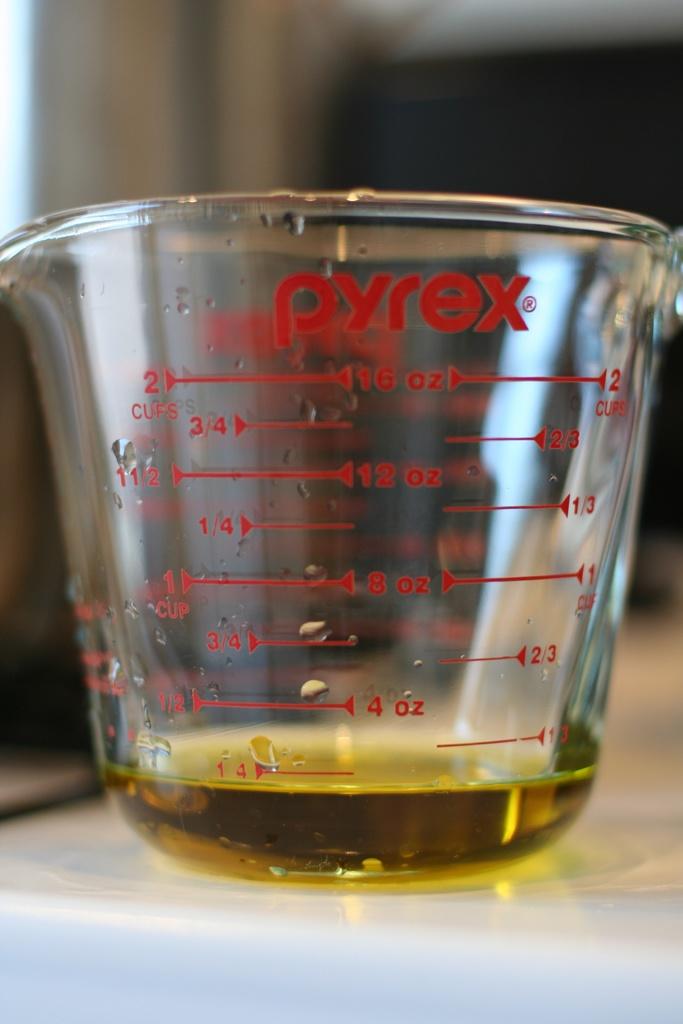What is the oil measurement?
Keep it short and to the point. 1/4 cup. What brand produced this measuring cup?
Give a very brief answer. Pyrex. 